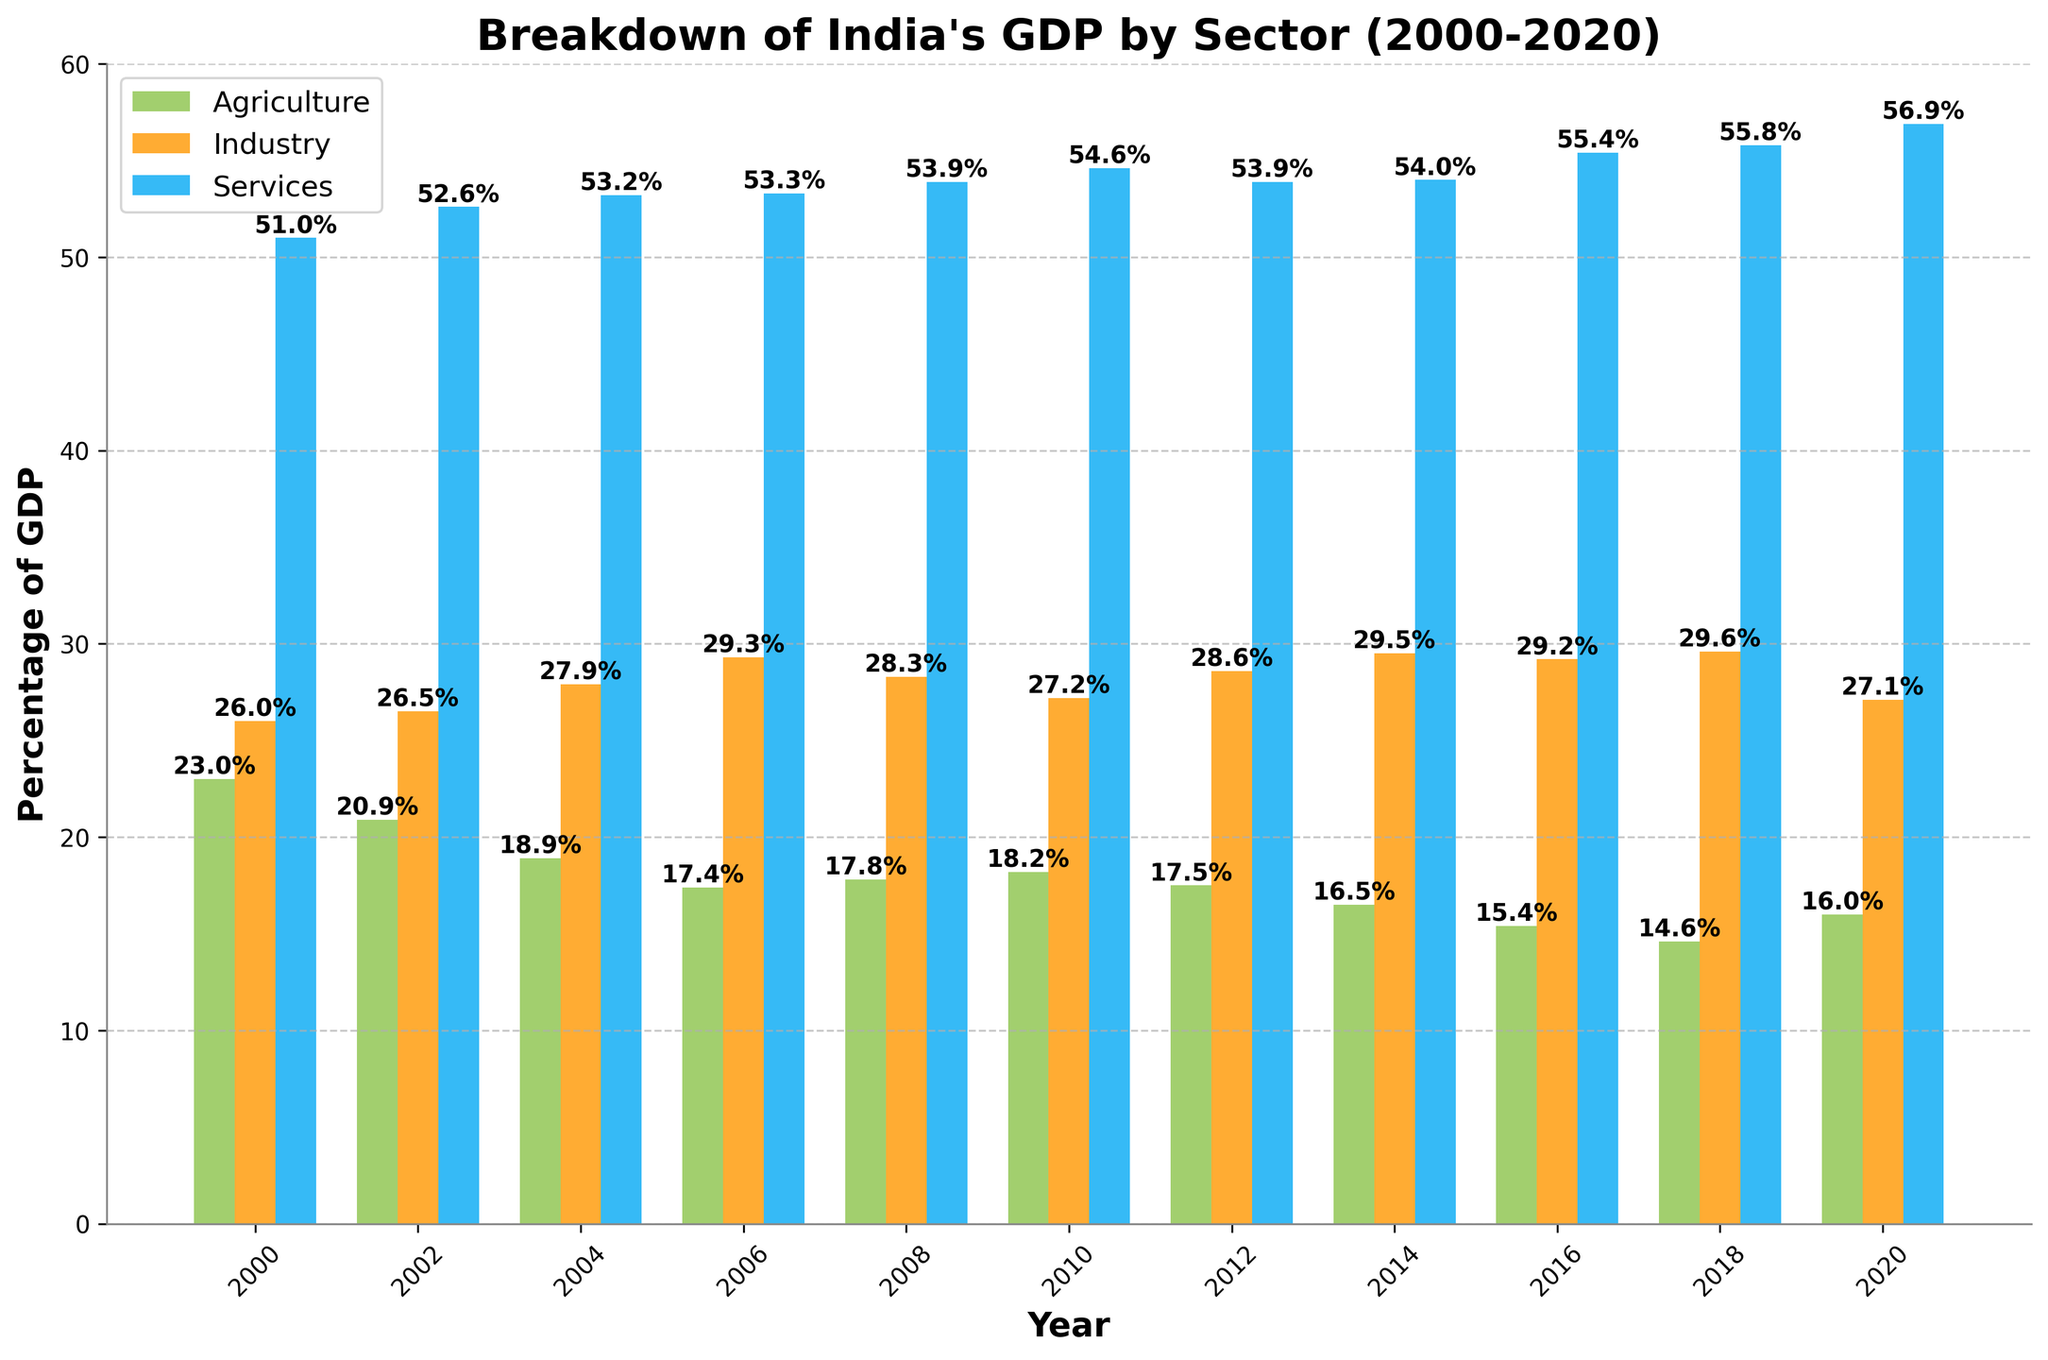What was the percentage change in the Agriculture sector from 2000 to 2020? To find the percentage change, subtract the value in 2020 from the value in 2000 and then divide by the value in 2000. Finally, multiply by 100: ((16.0 - 23.0) / 23.0) * 100 = -30.43%
Answer: -30.43% In which year did the Industry sector contribute the most to India's GDP? By examining the height of the bars for the Industry sector across years, the highest contribution is in the year 2014 at 29.5%.
Answer: 2014 Which sector had the highest percentage of GDP in 2018? By comparing the heights of the bars for the year 2018, the Services sector has the highest percentage at 55.8%.
Answer: Services What is the total contribution of all three sectors to India's GDP in 2010? Sum the contributions of Agriculture, Industry, and Services in 2010: 18.2 + 27.2 + 54.6 = 100%
Answer: 100% How does the Services sector's contribution in 2000 compare to its contribution in 2020? The contribution in 2000 is 51.0% and in 2020 is 56.9%. By subtracting the value of 2000 from the value of 2020, we get: 56.9 - 51.0 = 5.9% increase.
Answer: 5.9% Between 2006 and 2016, which sector showed the least amount of change in its contribution to India's GDP? Calculate the change for each sector over these years: 
Agriculture: 15.4 - 17.4 = -2.0% 
Industry: 29.2 - 29.3 = -0.1% 
Services: 55.4 - 53.3 = 2.1% 
The smallest change is in Industry at -0.1%.
Answer: Industry Which sector's contribution decreased the most from 2004 to 2008? Compare the changes in contributions from 2004 to 2008 for each sector: 
Agriculture: 17.8 - 18.9 = -1.1% 
Industry: 28.3 - 27.9 = -0.4% 
Services: 53.9 - 53.2 = +0.7% 
Agriculture shows the largest decrease at -1.1%.
Answer: Agriculture What's the average GDP contribution of the Industry sector over the years 2000, 2006, and 2012? Add the contributions for these years and divide by 3: (26.0 + 29.3 + 28.6) / 3 = 27.97%
Answer: 27.97% In which year did the Agriculture sector have its lowest contribution, and what was the value? By finding the shortest bar for the Agriculture sector, it is in 2018 at 14.6%.
Answer: 2018, 14.6% How has the contribution of the Services sector changed from 2008 to 2018? Subtract the 2008 value from the 2018 value: 55.8 - 53.9 = 1.9% increase.
Answer: 1.9% 